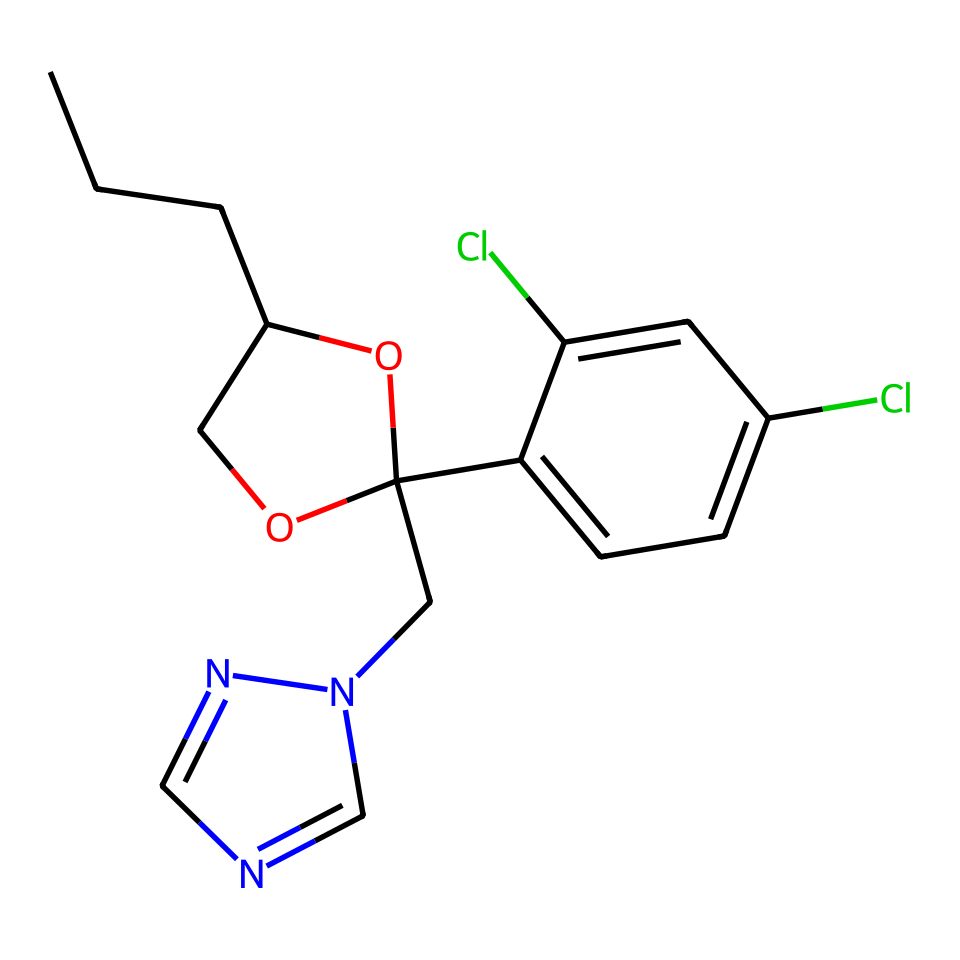What is the main functional group in propiconazole? The chemical structure includes a hydroxyl group (–OH) as indicated by the 'O' connected to a carbon atom in the cyclic structure. This functional group is characteristic of alcohols.
Answer: hydroxyl group How many chlorine atoms are present in the structure? By examining the structure, we see two 'Cl' notations indicating the presence of chlorine atoms, both attached to separate aromatic rings in the compound.
Answer: 2 What type of compound is propiconazole classified as? The presence of the nitrogen-containing ring along with other functionalities indicates that it falls under disease control chemicals, specifically fungicides. Thus, it's classified as a fungicide.
Answer: fungicide What is the total number of carbon atoms in this chemical? Counting the 'C' symbols in the SMILES representation and considering the carbon atoms in the aromatic ring structure leads to a total count of 15 carbon atoms.
Answer: 15 Which part of the chemical suggests it has antifungal properties? The structure contains a triazole ring (indicated by 'n2cncn2'), which is known for its mode of action against fungi by inhibiting ergosterol synthesis. This characteristic is common among fungicides.
Answer: triazole ring Does the compound have any double bonds? Looking at the structure, particularly at the rings and the connectivities of carbon, it is evident that there are no 'double bond' character indications such as '=' in the provided SMILES; thus, it is saturated.
Answer: no 